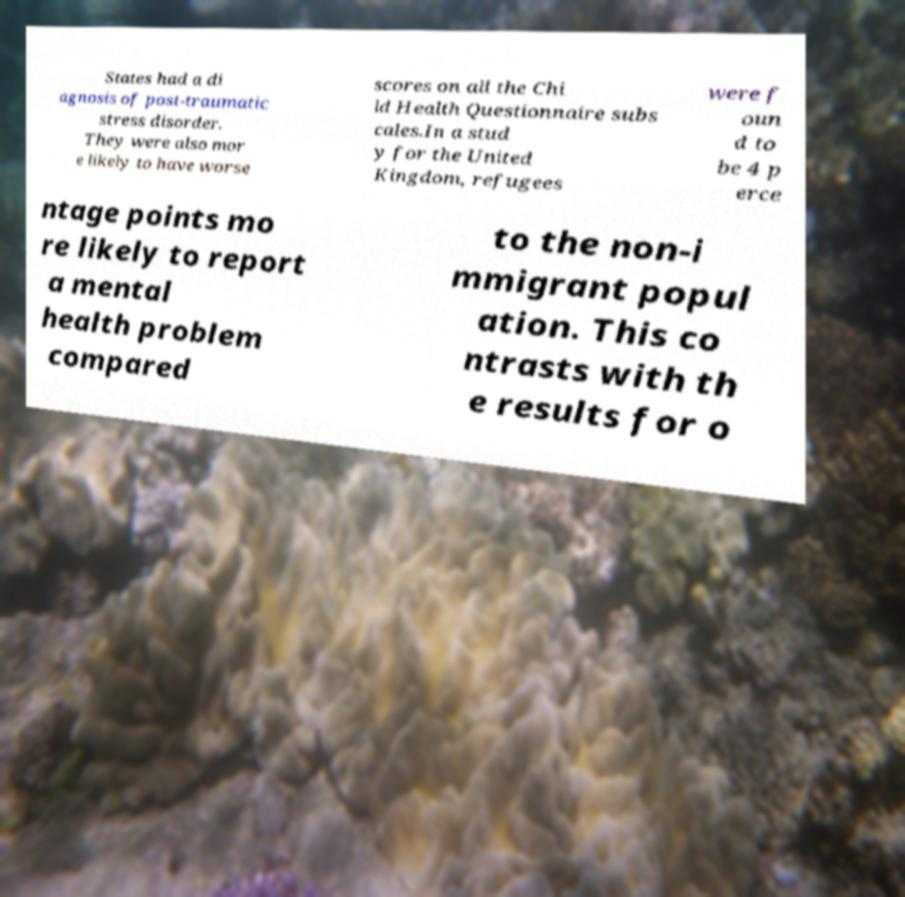Please read and relay the text visible in this image. What does it say? States had a di agnosis of post-traumatic stress disorder. They were also mor e likely to have worse scores on all the Chi ld Health Questionnaire subs cales.In a stud y for the United Kingdom, refugees were f oun d to be 4 p erce ntage points mo re likely to report a mental health problem compared to the non-i mmigrant popul ation. This co ntrasts with th e results for o 